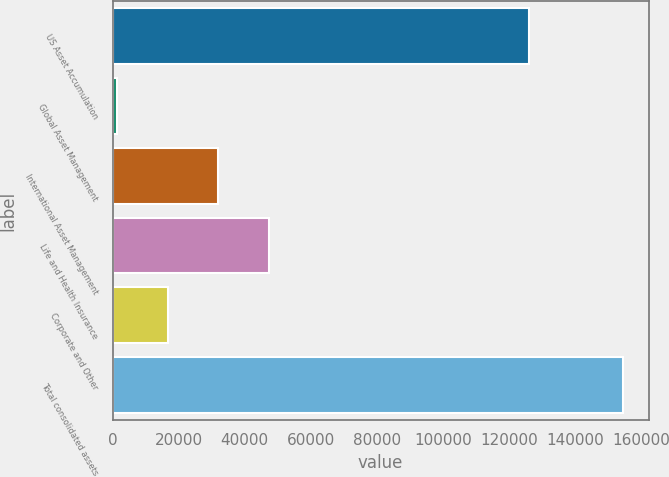Convert chart. <chart><loc_0><loc_0><loc_500><loc_500><bar_chart><fcel>US Asset Accumulation<fcel>Global Asset Management<fcel>International Asset Management<fcel>Life and Health Insurance<fcel>Corporate and Other<fcel>Total consolidated assets<nl><fcel>126131<fcel>1438.9<fcel>32055.2<fcel>47363.3<fcel>16747<fcel>154520<nl></chart> 